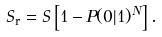Convert formula to latex. <formula><loc_0><loc_0><loc_500><loc_500>S _ { \text {r} } = S \left [ 1 - P ( 0 | 1 ) ^ { N } \right ] .</formula> 